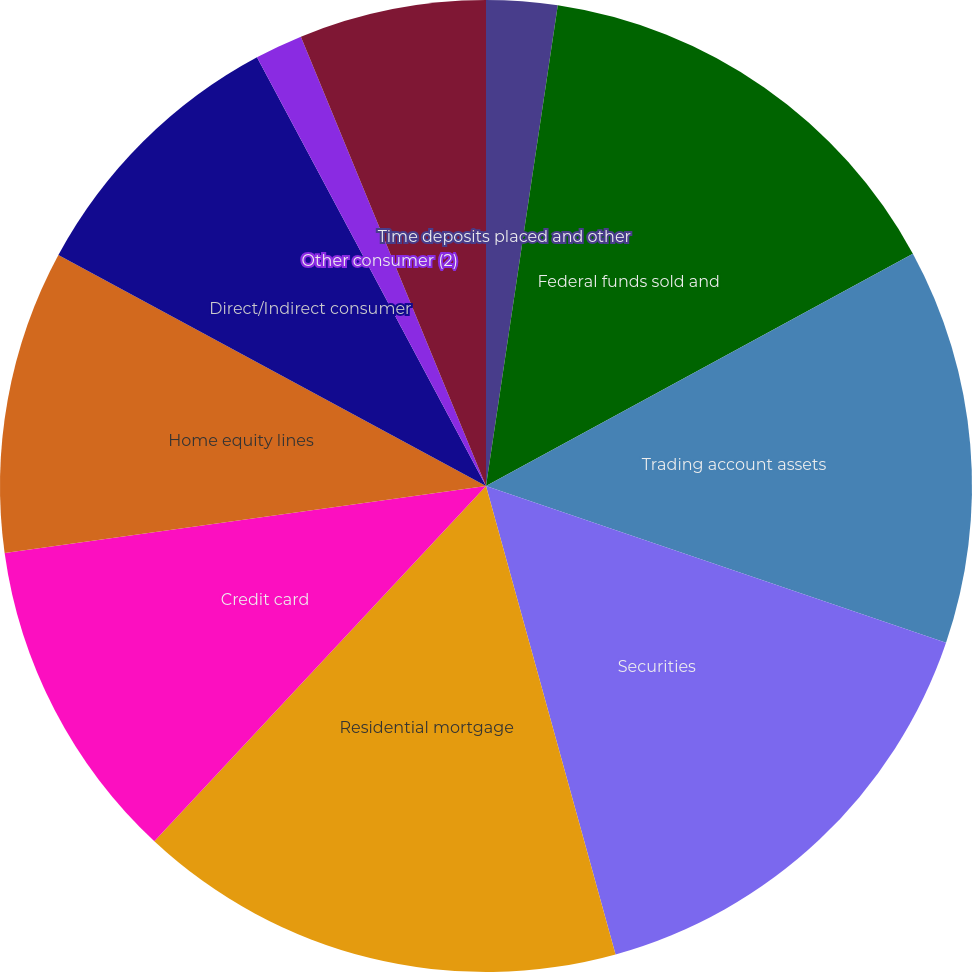Convert chart to OTSL. <chart><loc_0><loc_0><loc_500><loc_500><pie_chart><fcel>Time deposits placed and other<fcel>Federal funds sold and<fcel>Trading account assets<fcel>Securities<fcel>Residential mortgage<fcel>Credit card<fcel>Home equity lines<fcel>Direct/Indirect consumer<fcel>Other consumer (2)<fcel>Commercial real estate<nl><fcel>2.36%<fcel>14.71%<fcel>13.16%<fcel>15.48%<fcel>16.25%<fcel>10.85%<fcel>10.08%<fcel>9.31%<fcel>1.59%<fcel>6.22%<nl></chart> 